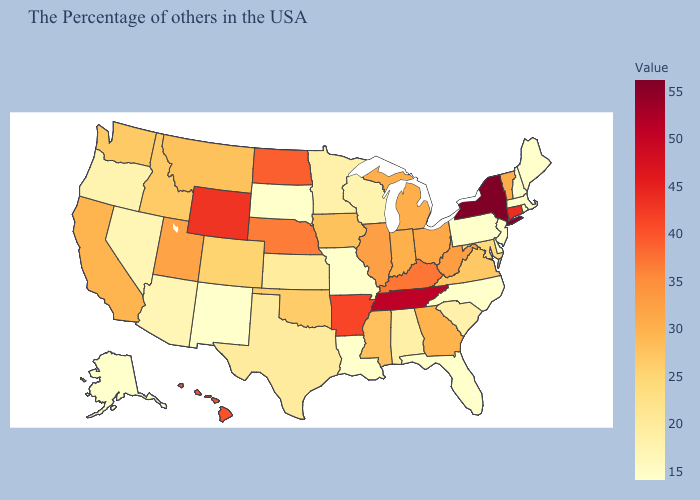Does Mississippi have the highest value in the South?
Concise answer only. No. Is the legend a continuous bar?
Concise answer only. Yes. Is the legend a continuous bar?
Be succinct. Yes. Among the states that border New Hampshire , which have the lowest value?
Concise answer only. Maine, Massachusetts. Among the states that border Arizona , does Utah have the highest value?
Keep it brief. Yes. Which states have the lowest value in the USA?
Short answer required. Maine, Massachusetts, New Hampshire, New Jersey, Delaware, Pennsylvania, North Carolina, Florida, Louisiana, Missouri, South Dakota, New Mexico, Alaska. Is the legend a continuous bar?
Give a very brief answer. Yes. 